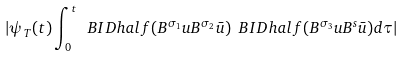<formula> <loc_0><loc_0><loc_500><loc_500>| \psi _ { T } ( t ) \int _ { 0 } ^ { t } \ B I D h a l f ( B ^ { \sigma _ { 1 } } u B ^ { \sigma _ { 2 } } { \bar { u } } ) \ B I D h a l f ( B ^ { \sigma _ { 3 } } u B ^ { s } { \bar { u } } ) d \tau |</formula> 